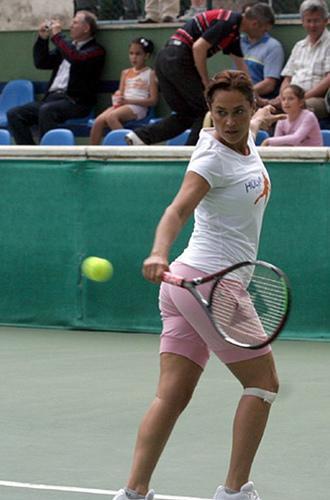How many people are holding rackets?
Give a very brief answer. 1. 